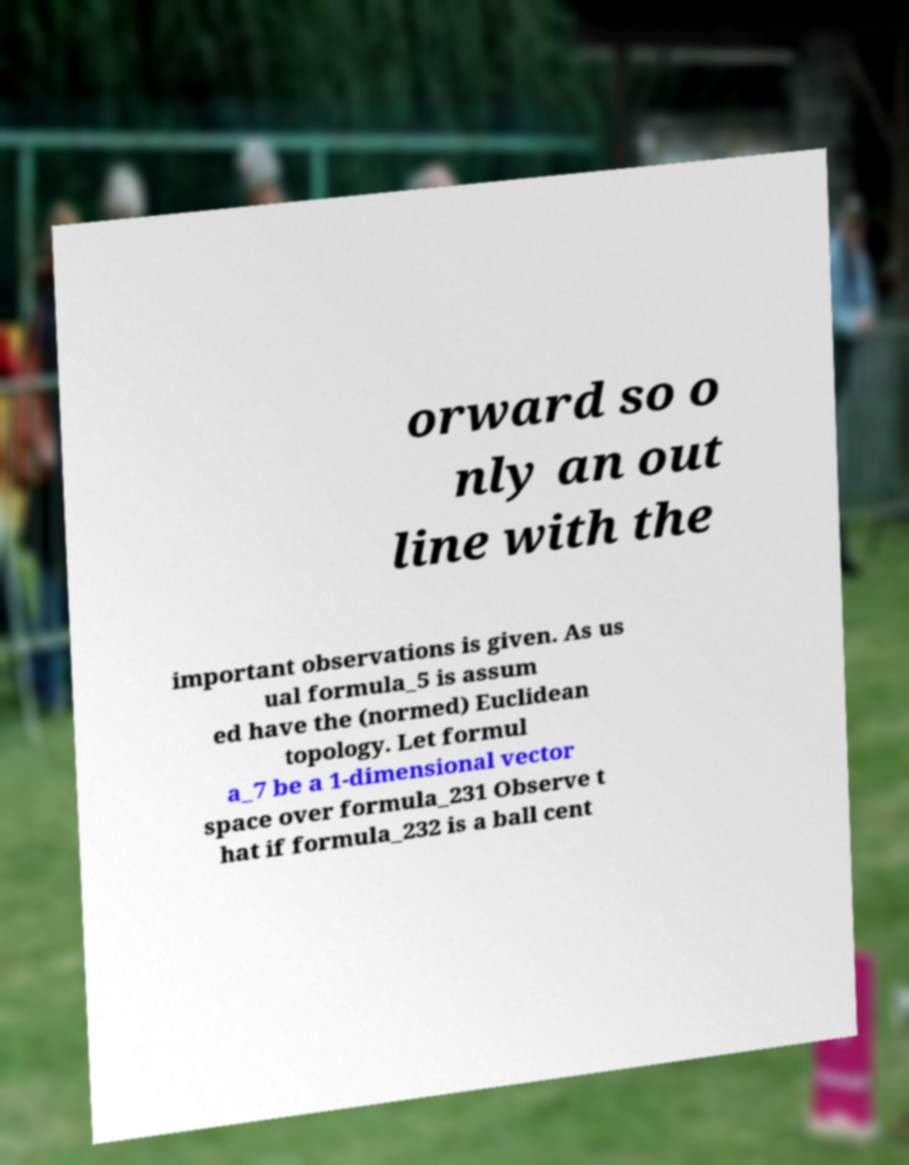Can you read and provide the text displayed in the image?This photo seems to have some interesting text. Can you extract and type it out for me? orward so o nly an out line with the important observations is given. As us ual formula_5 is assum ed have the (normed) Euclidean topology. Let formul a_7 be a 1-dimensional vector space over formula_231 Observe t hat if formula_232 is a ball cent 